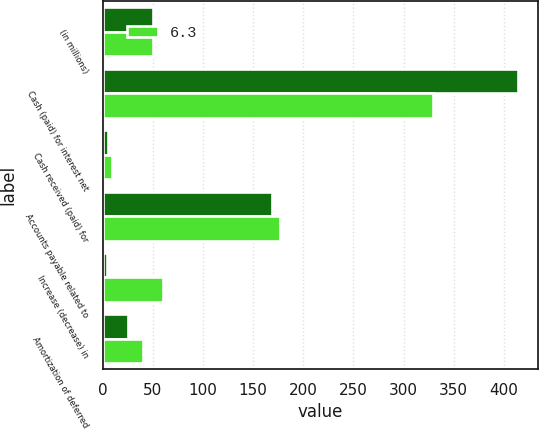Convert chart to OTSL. <chart><loc_0><loc_0><loc_500><loc_500><stacked_bar_chart><ecel><fcel>(in millions)<fcel>Cash (paid) for interest net<fcel>Cash received (paid) for<fcel>Accounts payable related to<fcel>Increase (decrease) in<fcel>Amortization of deferred<nl><fcel>nan<fcel>50.05<fcel>413.7<fcel>5.2<fcel>169.2<fcel>4.6<fcel>24.9<nl><fcel>6.3<fcel>50.05<fcel>329.6<fcel>9.3<fcel>177.1<fcel>60.2<fcel>39.9<nl></chart> 